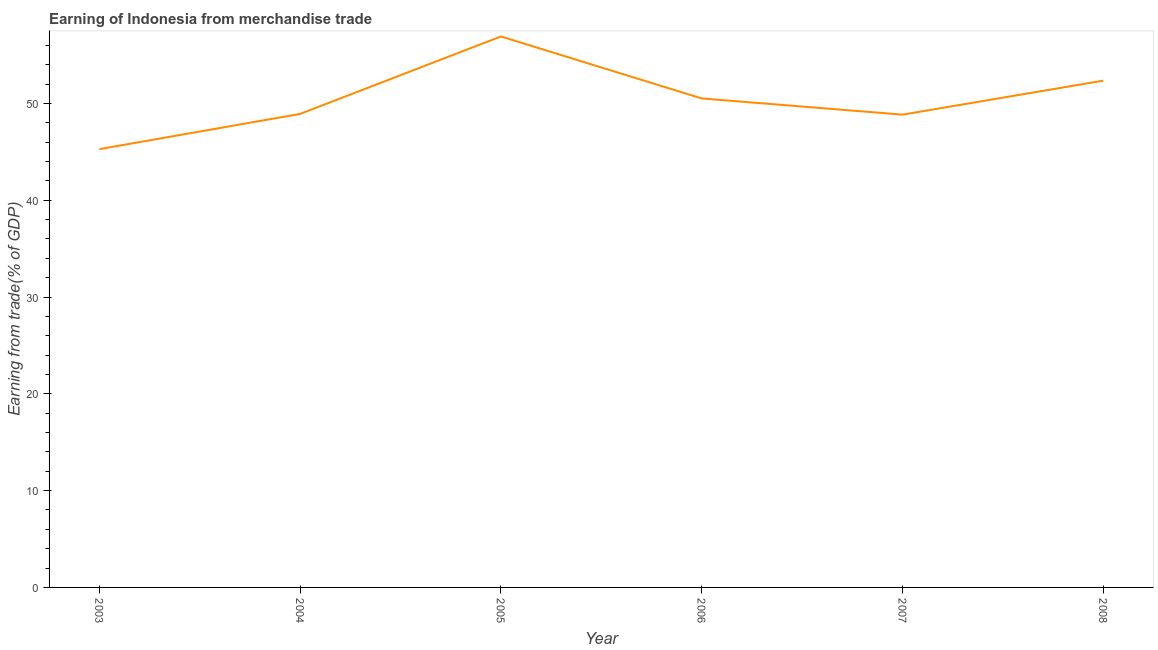What is the earning from merchandise trade in 2008?
Provide a succinct answer. 52.36. Across all years, what is the maximum earning from merchandise trade?
Give a very brief answer. 56.92. Across all years, what is the minimum earning from merchandise trade?
Make the answer very short. 45.28. What is the sum of the earning from merchandise trade?
Ensure brevity in your answer.  302.84. What is the difference between the earning from merchandise trade in 2005 and 2008?
Your answer should be very brief. 4.56. What is the average earning from merchandise trade per year?
Your response must be concise. 50.47. What is the median earning from merchandise trade?
Offer a terse response. 49.72. In how many years, is the earning from merchandise trade greater than 48 %?
Make the answer very short. 5. Do a majority of the years between 2005 and 2007 (inclusive) have earning from merchandise trade greater than 26 %?
Make the answer very short. Yes. What is the ratio of the earning from merchandise trade in 2003 to that in 2007?
Ensure brevity in your answer.  0.93. Is the earning from merchandise trade in 2003 less than that in 2008?
Make the answer very short. Yes. Is the difference between the earning from merchandise trade in 2003 and 2005 greater than the difference between any two years?
Make the answer very short. Yes. What is the difference between the highest and the second highest earning from merchandise trade?
Provide a succinct answer. 4.56. Is the sum of the earning from merchandise trade in 2004 and 2005 greater than the maximum earning from merchandise trade across all years?
Offer a very short reply. Yes. What is the difference between the highest and the lowest earning from merchandise trade?
Give a very brief answer. 11.64. How many years are there in the graph?
Give a very brief answer. 6. What is the title of the graph?
Your response must be concise. Earning of Indonesia from merchandise trade. What is the label or title of the Y-axis?
Make the answer very short. Earning from trade(% of GDP). What is the Earning from trade(% of GDP) of 2003?
Your answer should be very brief. 45.28. What is the Earning from trade(% of GDP) in 2004?
Your response must be concise. 48.92. What is the Earning from trade(% of GDP) in 2005?
Your answer should be compact. 56.92. What is the Earning from trade(% of GDP) of 2006?
Provide a succinct answer. 50.52. What is the Earning from trade(% of GDP) in 2007?
Your response must be concise. 48.84. What is the Earning from trade(% of GDP) in 2008?
Give a very brief answer. 52.36. What is the difference between the Earning from trade(% of GDP) in 2003 and 2004?
Provide a succinct answer. -3.64. What is the difference between the Earning from trade(% of GDP) in 2003 and 2005?
Your response must be concise. -11.64. What is the difference between the Earning from trade(% of GDP) in 2003 and 2006?
Provide a succinct answer. -5.24. What is the difference between the Earning from trade(% of GDP) in 2003 and 2007?
Offer a terse response. -3.56. What is the difference between the Earning from trade(% of GDP) in 2003 and 2008?
Offer a very short reply. -7.08. What is the difference between the Earning from trade(% of GDP) in 2004 and 2005?
Your response must be concise. -8. What is the difference between the Earning from trade(% of GDP) in 2004 and 2006?
Offer a very short reply. -1.6. What is the difference between the Earning from trade(% of GDP) in 2004 and 2007?
Keep it short and to the point. 0.08. What is the difference between the Earning from trade(% of GDP) in 2004 and 2008?
Your answer should be very brief. -3.44. What is the difference between the Earning from trade(% of GDP) in 2005 and 2006?
Offer a very short reply. 6.4. What is the difference between the Earning from trade(% of GDP) in 2005 and 2007?
Keep it short and to the point. 8.08. What is the difference between the Earning from trade(% of GDP) in 2005 and 2008?
Offer a very short reply. 4.56. What is the difference between the Earning from trade(% of GDP) in 2006 and 2007?
Make the answer very short. 1.67. What is the difference between the Earning from trade(% of GDP) in 2006 and 2008?
Your answer should be very brief. -1.84. What is the difference between the Earning from trade(% of GDP) in 2007 and 2008?
Give a very brief answer. -3.51. What is the ratio of the Earning from trade(% of GDP) in 2003 to that in 2004?
Make the answer very short. 0.93. What is the ratio of the Earning from trade(% of GDP) in 2003 to that in 2005?
Keep it short and to the point. 0.8. What is the ratio of the Earning from trade(% of GDP) in 2003 to that in 2006?
Provide a succinct answer. 0.9. What is the ratio of the Earning from trade(% of GDP) in 2003 to that in 2007?
Provide a short and direct response. 0.93. What is the ratio of the Earning from trade(% of GDP) in 2003 to that in 2008?
Offer a very short reply. 0.86. What is the ratio of the Earning from trade(% of GDP) in 2004 to that in 2005?
Keep it short and to the point. 0.86. What is the ratio of the Earning from trade(% of GDP) in 2004 to that in 2008?
Make the answer very short. 0.93. What is the ratio of the Earning from trade(% of GDP) in 2005 to that in 2006?
Provide a succinct answer. 1.13. What is the ratio of the Earning from trade(% of GDP) in 2005 to that in 2007?
Your response must be concise. 1.17. What is the ratio of the Earning from trade(% of GDP) in 2005 to that in 2008?
Offer a terse response. 1.09. What is the ratio of the Earning from trade(% of GDP) in 2006 to that in 2007?
Make the answer very short. 1.03. What is the ratio of the Earning from trade(% of GDP) in 2007 to that in 2008?
Your response must be concise. 0.93. 